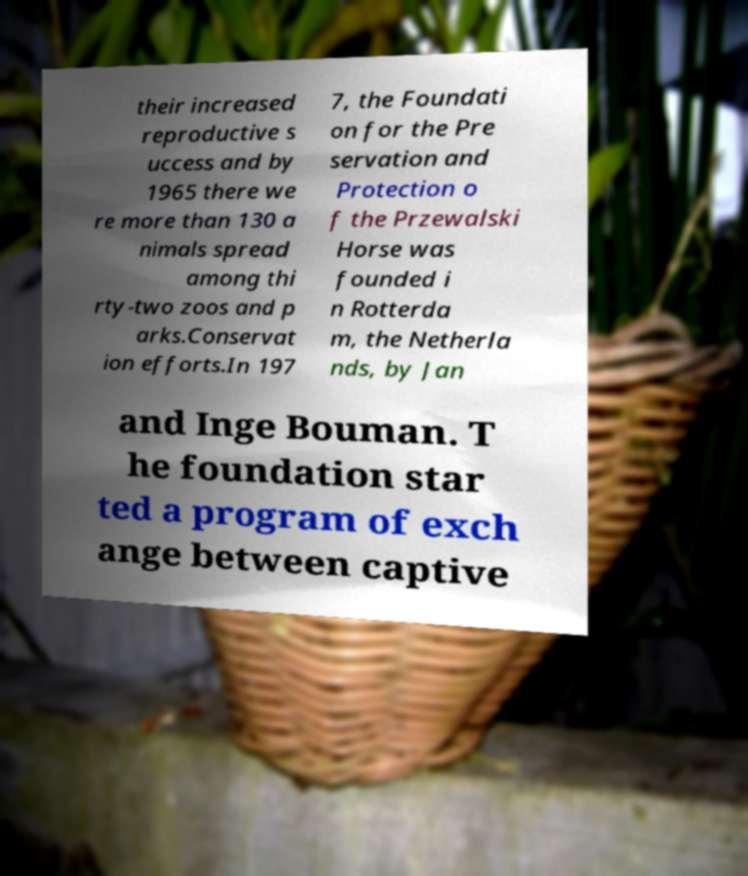Please identify and transcribe the text found in this image. their increased reproductive s uccess and by 1965 there we re more than 130 a nimals spread among thi rty-two zoos and p arks.Conservat ion efforts.In 197 7, the Foundati on for the Pre servation and Protection o f the Przewalski Horse was founded i n Rotterda m, the Netherla nds, by Jan and Inge Bouman. T he foundation star ted a program of exch ange between captive 